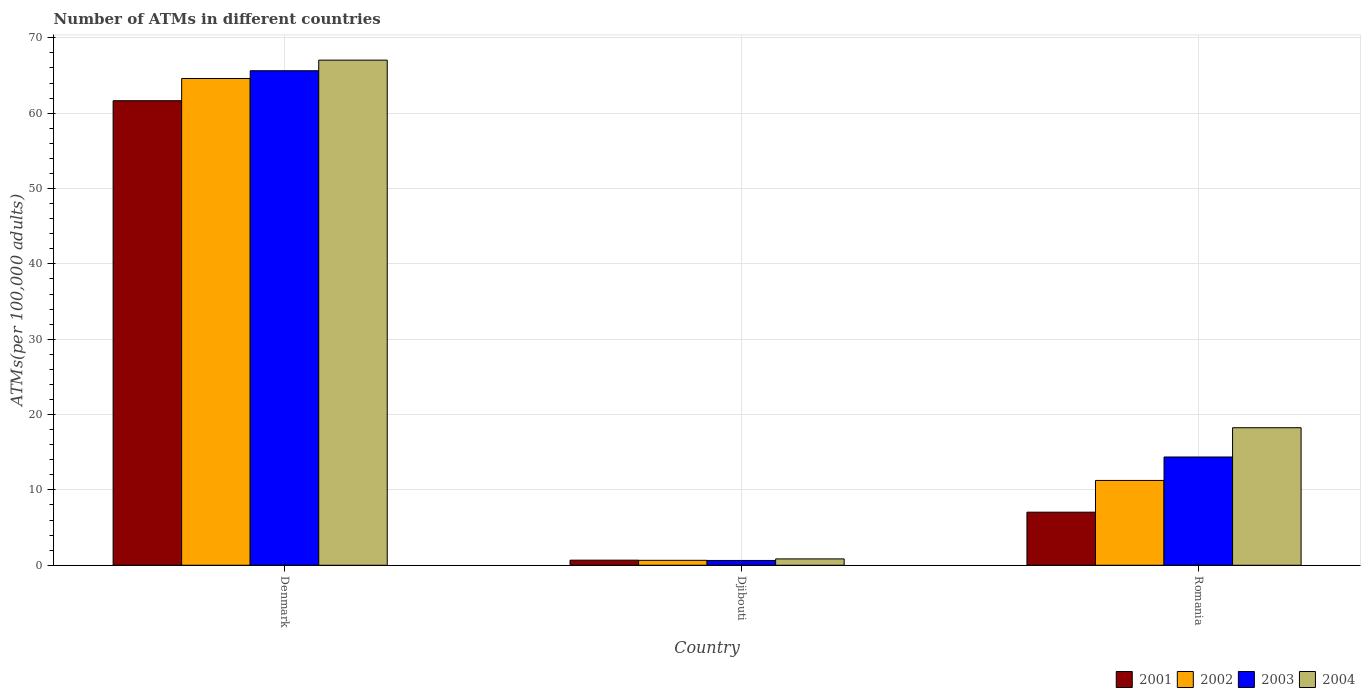How many different coloured bars are there?
Your response must be concise. 4. Are the number of bars per tick equal to the number of legend labels?
Give a very brief answer. Yes. Are the number of bars on each tick of the X-axis equal?
Your answer should be compact. Yes. What is the label of the 3rd group of bars from the left?
Provide a succinct answer. Romania. What is the number of ATMs in 2004 in Denmark?
Ensure brevity in your answer.  67.04. Across all countries, what is the maximum number of ATMs in 2001?
Give a very brief answer. 61.66. Across all countries, what is the minimum number of ATMs in 2003?
Give a very brief answer. 0.64. In which country was the number of ATMs in 2002 minimum?
Ensure brevity in your answer.  Djibouti. What is the total number of ATMs in 2003 in the graph?
Offer a terse response. 80.65. What is the difference between the number of ATMs in 2002 in Denmark and that in Romania?
Provide a succinct answer. 53.35. What is the difference between the number of ATMs in 2004 in Denmark and the number of ATMs in 2003 in Romania?
Offer a terse response. 52.67. What is the average number of ATMs in 2004 per country?
Provide a short and direct response. 28.71. What is the difference between the number of ATMs of/in 2004 and number of ATMs of/in 2001 in Djibouti?
Your answer should be very brief. 0.17. What is the ratio of the number of ATMs in 2001 in Djibouti to that in Romania?
Keep it short and to the point. 0.1. What is the difference between the highest and the second highest number of ATMs in 2002?
Offer a very short reply. 63.95. What is the difference between the highest and the lowest number of ATMs in 2001?
Offer a terse response. 60.98. In how many countries, is the number of ATMs in 2002 greater than the average number of ATMs in 2002 taken over all countries?
Provide a short and direct response. 1. Is the sum of the number of ATMs in 2004 in Djibouti and Romania greater than the maximum number of ATMs in 2003 across all countries?
Ensure brevity in your answer.  No. Is it the case that in every country, the sum of the number of ATMs in 2004 and number of ATMs in 2002 is greater than the number of ATMs in 2003?
Your answer should be compact. Yes. How many bars are there?
Your answer should be compact. 12. How many countries are there in the graph?
Provide a short and direct response. 3. What is the difference between two consecutive major ticks on the Y-axis?
Make the answer very short. 10. Does the graph contain any zero values?
Offer a terse response. No. Where does the legend appear in the graph?
Your answer should be compact. Bottom right. How many legend labels are there?
Offer a terse response. 4. How are the legend labels stacked?
Offer a terse response. Horizontal. What is the title of the graph?
Your response must be concise. Number of ATMs in different countries. Does "1996" appear as one of the legend labels in the graph?
Your response must be concise. No. What is the label or title of the X-axis?
Your answer should be very brief. Country. What is the label or title of the Y-axis?
Offer a very short reply. ATMs(per 100,0 adults). What is the ATMs(per 100,000 adults) of 2001 in Denmark?
Provide a short and direct response. 61.66. What is the ATMs(per 100,000 adults) of 2002 in Denmark?
Your answer should be very brief. 64.61. What is the ATMs(per 100,000 adults) in 2003 in Denmark?
Make the answer very short. 65.64. What is the ATMs(per 100,000 adults) of 2004 in Denmark?
Give a very brief answer. 67.04. What is the ATMs(per 100,000 adults) in 2001 in Djibouti?
Provide a short and direct response. 0.68. What is the ATMs(per 100,000 adults) of 2002 in Djibouti?
Make the answer very short. 0.66. What is the ATMs(per 100,000 adults) in 2003 in Djibouti?
Offer a very short reply. 0.64. What is the ATMs(per 100,000 adults) in 2004 in Djibouti?
Your answer should be compact. 0.84. What is the ATMs(per 100,000 adults) of 2001 in Romania?
Ensure brevity in your answer.  7.04. What is the ATMs(per 100,000 adults) in 2002 in Romania?
Give a very brief answer. 11.26. What is the ATMs(per 100,000 adults) in 2003 in Romania?
Your answer should be very brief. 14.37. What is the ATMs(per 100,000 adults) in 2004 in Romania?
Make the answer very short. 18.26. Across all countries, what is the maximum ATMs(per 100,000 adults) of 2001?
Give a very brief answer. 61.66. Across all countries, what is the maximum ATMs(per 100,000 adults) in 2002?
Keep it short and to the point. 64.61. Across all countries, what is the maximum ATMs(per 100,000 adults) of 2003?
Provide a short and direct response. 65.64. Across all countries, what is the maximum ATMs(per 100,000 adults) in 2004?
Provide a succinct answer. 67.04. Across all countries, what is the minimum ATMs(per 100,000 adults) of 2001?
Keep it short and to the point. 0.68. Across all countries, what is the minimum ATMs(per 100,000 adults) of 2002?
Ensure brevity in your answer.  0.66. Across all countries, what is the minimum ATMs(per 100,000 adults) of 2003?
Your answer should be compact. 0.64. Across all countries, what is the minimum ATMs(per 100,000 adults) in 2004?
Keep it short and to the point. 0.84. What is the total ATMs(per 100,000 adults) of 2001 in the graph?
Your answer should be very brief. 69.38. What is the total ATMs(per 100,000 adults) of 2002 in the graph?
Ensure brevity in your answer.  76.52. What is the total ATMs(per 100,000 adults) in 2003 in the graph?
Offer a very short reply. 80.65. What is the total ATMs(per 100,000 adults) of 2004 in the graph?
Your answer should be compact. 86.14. What is the difference between the ATMs(per 100,000 adults) of 2001 in Denmark and that in Djibouti?
Offer a very short reply. 60.98. What is the difference between the ATMs(per 100,000 adults) of 2002 in Denmark and that in Djibouti?
Your answer should be very brief. 63.95. What is the difference between the ATMs(per 100,000 adults) in 2003 in Denmark and that in Djibouti?
Offer a terse response. 65. What is the difference between the ATMs(per 100,000 adults) of 2004 in Denmark and that in Djibouti?
Your answer should be compact. 66.2. What is the difference between the ATMs(per 100,000 adults) in 2001 in Denmark and that in Romania?
Ensure brevity in your answer.  54.61. What is the difference between the ATMs(per 100,000 adults) of 2002 in Denmark and that in Romania?
Offer a terse response. 53.35. What is the difference between the ATMs(per 100,000 adults) in 2003 in Denmark and that in Romania?
Ensure brevity in your answer.  51.27. What is the difference between the ATMs(per 100,000 adults) in 2004 in Denmark and that in Romania?
Your answer should be very brief. 48.79. What is the difference between the ATMs(per 100,000 adults) of 2001 in Djibouti and that in Romania?
Make the answer very short. -6.37. What is the difference between the ATMs(per 100,000 adults) in 2002 in Djibouti and that in Romania?
Provide a short and direct response. -10.6. What is the difference between the ATMs(per 100,000 adults) in 2003 in Djibouti and that in Romania?
Provide a succinct answer. -13.73. What is the difference between the ATMs(per 100,000 adults) of 2004 in Djibouti and that in Romania?
Give a very brief answer. -17.41. What is the difference between the ATMs(per 100,000 adults) of 2001 in Denmark and the ATMs(per 100,000 adults) of 2002 in Djibouti?
Offer a very short reply. 61. What is the difference between the ATMs(per 100,000 adults) in 2001 in Denmark and the ATMs(per 100,000 adults) in 2003 in Djibouti?
Offer a very short reply. 61.02. What is the difference between the ATMs(per 100,000 adults) of 2001 in Denmark and the ATMs(per 100,000 adults) of 2004 in Djibouti?
Your response must be concise. 60.81. What is the difference between the ATMs(per 100,000 adults) in 2002 in Denmark and the ATMs(per 100,000 adults) in 2003 in Djibouti?
Your answer should be compact. 63.97. What is the difference between the ATMs(per 100,000 adults) of 2002 in Denmark and the ATMs(per 100,000 adults) of 2004 in Djibouti?
Provide a short and direct response. 63.76. What is the difference between the ATMs(per 100,000 adults) in 2003 in Denmark and the ATMs(per 100,000 adults) in 2004 in Djibouti?
Your answer should be very brief. 64.79. What is the difference between the ATMs(per 100,000 adults) in 2001 in Denmark and the ATMs(per 100,000 adults) in 2002 in Romania?
Make the answer very short. 50.4. What is the difference between the ATMs(per 100,000 adults) of 2001 in Denmark and the ATMs(per 100,000 adults) of 2003 in Romania?
Keep it short and to the point. 47.29. What is the difference between the ATMs(per 100,000 adults) of 2001 in Denmark and the ATMs(per 100,000 adults) of 2004 in Romania?
Provide a succinct answer. 43.4. What is the difference between the ATMs(per 100,000 adults) of 2002 in Denmark and the ATMs(per 100,000 adults) of 2003 in Romania?
Offer a terse response. 50.24. What is the difference between the ATMs(per 100,000 adults) of 2002 in Denmark and the ATMs(per 100,000 adults) of 2004 in Romania?
Make the answer very short. 46.35. What is the difference between the ATMs(per 100,000 adults) in 2003 in Denmark and the ATMs(per 100,000 adults) in 2004 in Romania?
Provide a short and direct response. 47.38. What is the difference between the ATMs(per 100,000 adults) in 2001 in Djibouti and the ATMs(per 100,000 adults) in 2002 in Romania?
Keep it short and to the point. -10.58. What is the difference between the ATMs(per 100,000 adults) in 2001 in Djibouti and the ATMs(per 100,000 adults) in 2003 in Romania?
Give a very brief answer. -13.69. What is the difference between the ATMs(per 100,000 adults) in 2001 in Djibouti and the ATMs(per 100,000 adults) in 2004 in Romania?
Keep it short and to the point. -17.58. What is the difference between the ATMs(per 100,000 adults) in 2002 in Djibouti and the ATMs(per 100,000 adults) in 2003 in Romania?
Ensure brevity in your answer.  -13.71. What is the difference between the ATMs(per 100,000 adults) in 2002 in Djibouti and the ATMs(per 100,000 adults) in 2004 in Romania?
Provide a succinct answer. -17.6. What is the difference between the ATMs(per 100,000 adults) in 2003 in Djibouti and the ATMs(per 100,000 adults) in 2004 in Romania?
Your response must be concise. -17.62. What is the average ATMs(per 100,000 adults) of 2001 per country?
Your response must be concise. 23.13. What is the average ATMs(per 100,000 adults) of 2002 per country?
Provide a short and direct response. 25.51. What is the average ATMs(per 100,000 adults) in 2003 per country?
Offer a very short reply. 26.88. What is the average ATMs(per 100,000 adults) in 2004 per country?
Offer a very short reply. 28.71. What is the difference between the ATMs(per 100,000 adults) of 2001 and ATMs(per 100,000 adults) of 2002 in Denmark?
Provide a succinct answer. -2.95. What is the difference between the ATMs(per 100,000 adults) of 2001 and ATMs(per 100,000 adults) of 2003 in Denmark?
Make the answer very short. -3.98. What is the difference between the ATMs(per 100,000 adults) in 2001 and ATMs(per 100,000 adults) in 2004 in Denmark?
Ensure brevity in your answer.  -5.39. What is the difference between the ATMs(per 100,000 adults) of 2002 and ATMs(per 100,000 adults) of 2003 in Denmark?
Give a very brief answer. -1.03. What is the difference between the ATMs(per 100,000 adults) of 2002 and ATMs(per 100,000 adults) of 2004 in Denmark?
Give a very brief answer. -2.44. What is the difference between the ATMs(per 100,000 adults) of 2003 and ATMs(per 100,000 adults) of 2004 in Denmark?
Your answer should be compact. -1.41. What is the difference between the ATMs(per 100,000 adults) in 2001 and ATMs(per 100,000 adults) in 2002 in Djibouti?
Your answer should be very brief. 0.02. What is the difference between the ATMs(per 100,000 adults) in 2001 and ATMs(per 100,000 adults) in 2003 in Djibouti?
Provide a short and direct response. 0.04. What is the difference between the ATMs(per 100,000 adults) in 2001 and ATMs(per 100,000 adults) in 2004 in Djibouti?
Your answer should be compact. -0.17. What is the difference between the ATMs(per 100,000 adults) in 2002 and ATMs(per 100,000 adults) in 2003 in Djibouti?
Your answer should be compact. 0.02. What is the difference between the ATMs(per 100,000 adults) in 2002 and ATMs(per 100,000 adults) in 2004 in Djibouti?
Make the answer very short. -0.19. What is the difference between the ATMs(per 100,000 adults) in 2003 and ATMs(per 100,000 adults) in 2004 in Djibouti?
Your response must be concise. -0.21. What is the difference between the ATMs(per 100,000 adults) of 2001 and ATMs(per 100,000 adults) of 2002 in Romania?
Keep it short and to the point. -4.21. What is the difference between the ATMs(per 100,000 adults) in 2001 and ATMs(per 100,000 adults) in 2003 in Romania?
Your answer should be compact. -7.32. What is the difference between the ATMs(per 100,000 adults) in 2001 and ATMs(per 100,000 adults) in 2004 in Romania?
Offer a very short reply. -11.21. What is the difference between the ATMs(per 100,000 adults) in 2002 and ATMs(per 100,000 adults) in 2003 in Romania?
Your answer should be very brief. -3.11. What is the difference between the ATMs(per 100,000 adults) of 2002 and ATMs(per 100,000 adults) of 2004 in Romania?
Ensure brevity in your answer.  -7. What is the difference between the ATMs(per 100,000 adults) in 2003 and ATMs(per 100,000 adults) in 2004 in Romania?
Provide a short and direct response. -3.89. What is the ratio of the ATMs(per 100,000 adults) of 2001 in Denmark to that in Djibouti?
Make the answer very short. 91.18. What is the ratio of the ATMs(per 100,000 adults) of 2002 in Denmark to that in Djibouti?
Give a very brief answer. 98.45. What is the ratio of the ATMs(per 100,000 adults) of 2003 in Denmark to that in Djibouti?
Your answer should be very brief. 102.88. What is the ratio of the ATMs(per 100,000 adults) of 2004 in Denmark to that in Djibouti?
Ensure brevity in your answer.  79.46. What is the ratio of the ATMs(per 100,000 adults) of 2001 in Denmark to that in Romania?
Ensure brevity in your answer.  8.75. What is the ratio of the ATMs(per 100,000 adults) of 2002 in Denmark to that in Romania?
Your answer should be very brief. 5.74. What is the ratio of the ATMs(per 100,000 adults) in 2003 in Denmark to that in Romania?
Provide a short and direct response. 4.57. What is the ratio of the ATMs(per 100,000 adults) of 2004 in Denmark to that in Romania?
Offer a very short reply. 3.67. What is the ratio of the ATMs(per 100,000 adults) of 2001 in Djibouti to that in Romania?
Give a very brief answer. 0.1. What is the ratio of the ATMs(per 100,000 adults) in 2002 in Djibouti to that in Romania?
Keep it short and to the point. 0.06. What is the ratio of the ATMs(per 100,000 adults) in 2003 in Djibouti to that in Romania?
Give a very brief answer. 0.04. What is the ratio of the ATMs(per 100,000 adults) in 2004 in Djibouti to that in Romania?
Ensure brevity in your answer.  0.05. What is the difference between the highest and the second highest ATMs(per 100,000 adults) in 2001?
Your answer should be very brief. 54.61. What is the difference between the highest and the second highest ATMs(per 100,000 adults) of 2002?
Ensure brevity in your answer.  53.35. What is the difference between the highest and the second highest ATMs(per 100,000 adults) in 2003?
Offer a terse response. 51.27. What is the difference between the highest and the second highest ATMs(per 100,000 adults) in 2004?
Provide a succinct answer. 48.79. What is the difference between the highest and the lowest ATMs(per 100,000 adults) of 2001?
Keep it short and to the point. 60.98. What is the difference between the highest and the lowest ATMs(per 100,000 adults) in 2002?
Provide a short and direct response. 63.95. What is the difference between the highest and the lowest ATMs(per 100,000 adults) in 2003?
Your answer should be very brief. 65. What is the difference between the highest and the lowest ATMs(per 100,000 adults) of 2004?
Ensure brevity in your answer.  66.2. 